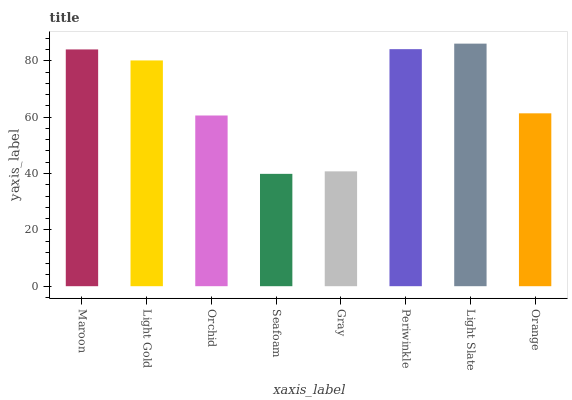Is Seafoam the minimum?
Answer yes or no. Yes. Is Light Slate the maximum?
Answer yes or no. Yes. Is Light Gold the minimum?
Answer yes or no. No. Is Light Gold the maximum?
Answer yes or no. No. Is Maroon greater than Light Gold?
Answer yes or no. Yes. Is Light Gold less than Maroon?
Answer yes or no. Yes. Is Light Gold greater than Maroon?
Answer yes or no. No. Is Maroon less than Light Gold?
Answer yes or no. No. Is Light Gold the high median?
Answer yes or no. Yes. Is Orange the low median?
Answer yes or no. Yes. Is Seafoam the high median?
Answer yes or no. No. Is Light Slate the low median?
Answer yes or no. No. 